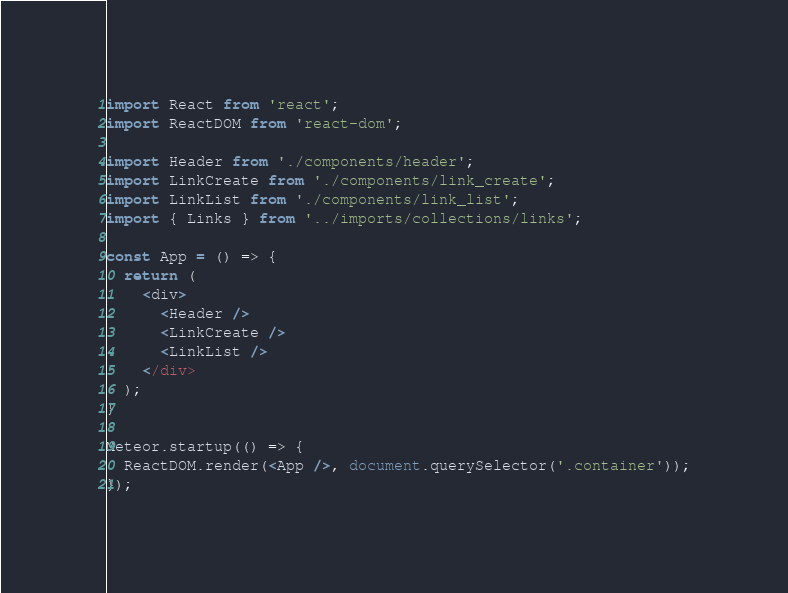Convert code to text. <code><loc_0><loc_0><loc_500><loc_500><_JavaScript_>import React from 'react';
import ReactDOM from 'react-dom';

import Header from './components/header';
import LinkCreate from './components/link_create';
import LinkList from './components/link_list';
import { Links } from '../imports/collections/links';

const App = () => {
  return (
    <div>
      <Header />
      <LinkCreate />
      <LinkList />
    </div>
  );
}

Meteor.startup(() => {
  ReactDOM.render(<App />, document.querySelector('.container'));
});</code> 